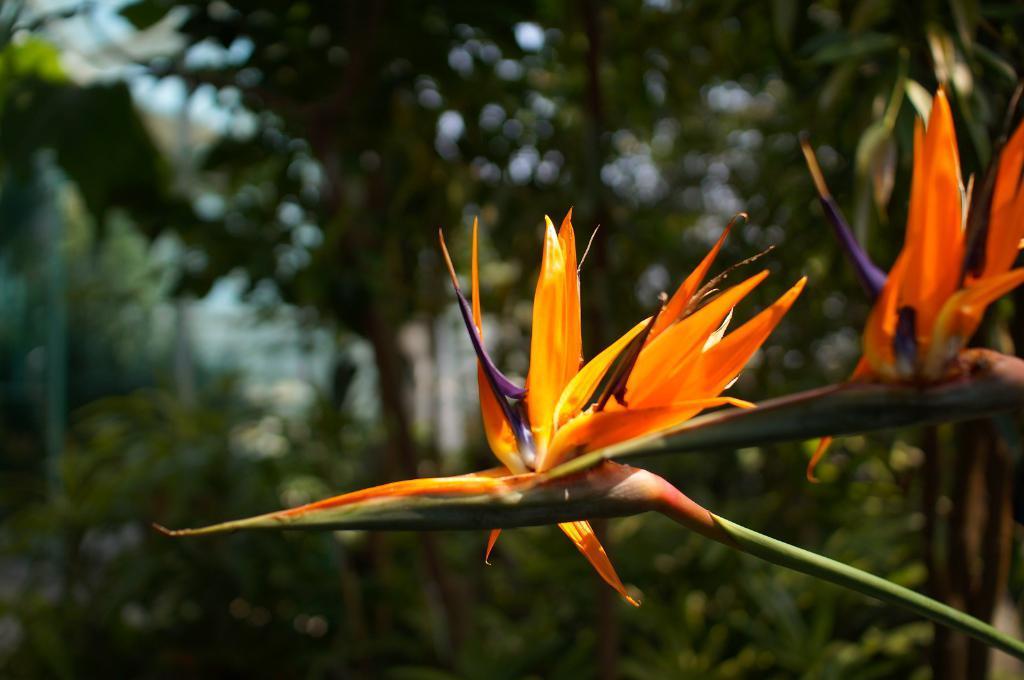Can you describe this image briefly? In this picture I can observe orange color flowers in the middle of the picture. In the background I can observe trees. 